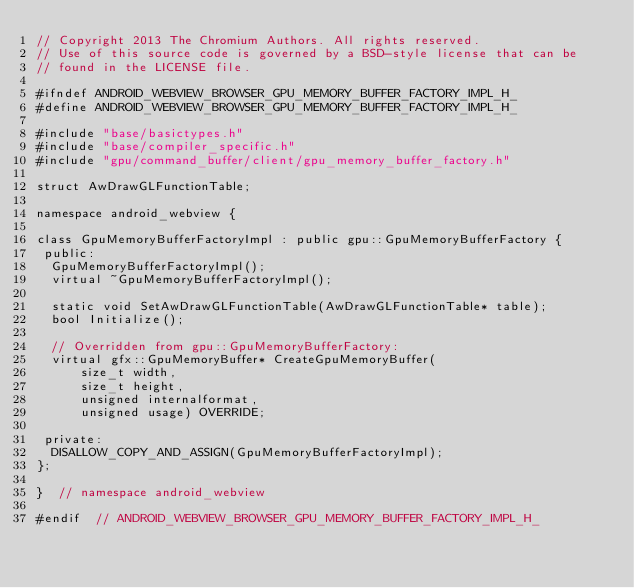Convert code to text. <code><loc_0><loc_0><loc_500><loc_500><_C_>// Copyright 2013 The Chromium Authors. All rights reserved.
// Use of this source code is governed by a BSD-style license that can be
// found in the LICENSE file.

#ifndef ANDROID_WEBVIEW_BROWSER_GPU_MEMORY_BUFFER_FACTORY_IMPL_H_
#define ANDROID_WEBVIEW_BROWSER_GPU_MEMORY_BUFFER_FACTORY_IMPL_H_

#include "base/basictypes.h"
#include "base/compiler_specific.h"
#include "gpu/command_buffer/client/gpu_memory_buffer_factory.h"

struct AwDrawGLFunctionTable;

namespace android_webview {

class GpuMemoryBufferFactoryImpl : public gpu::GpuMemoryBufferFactory {
 public:
  GpuMemoryBufferFactoryImpl();
  virtual ~GpuMemoryBufferFactoryImpl();

  static void SetAwDrawGLFunctionTable(AwDrawGLFunctionTable* table);
  bool Initialize();

  // Overridden from gpu::GpuMemoryBufferFactory:
  virtual gfx::GpuMemoryBuffer* CreateGpuMemoryBuffer(
      size_t width,
      size_t height,
      unsigned internalformat,
      unsigned usage) OVERRIDE;

 private:
  DISALLOW_COPY_AND_ASSIGN(GpuMemoryBufferFactoryImpl);
};

}  // namespace android_webview

#endif  // ANDROID_WEBVIEW_BROWSER_GPU_MEMORY_BUFFER_FACTORY_IMPL_H_
</code> 